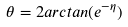<formula> <loc_0><loc_0><loc_500><loc_500>\theta = 2 a r c t a n ( e ^ { - \eta } )</formula> 